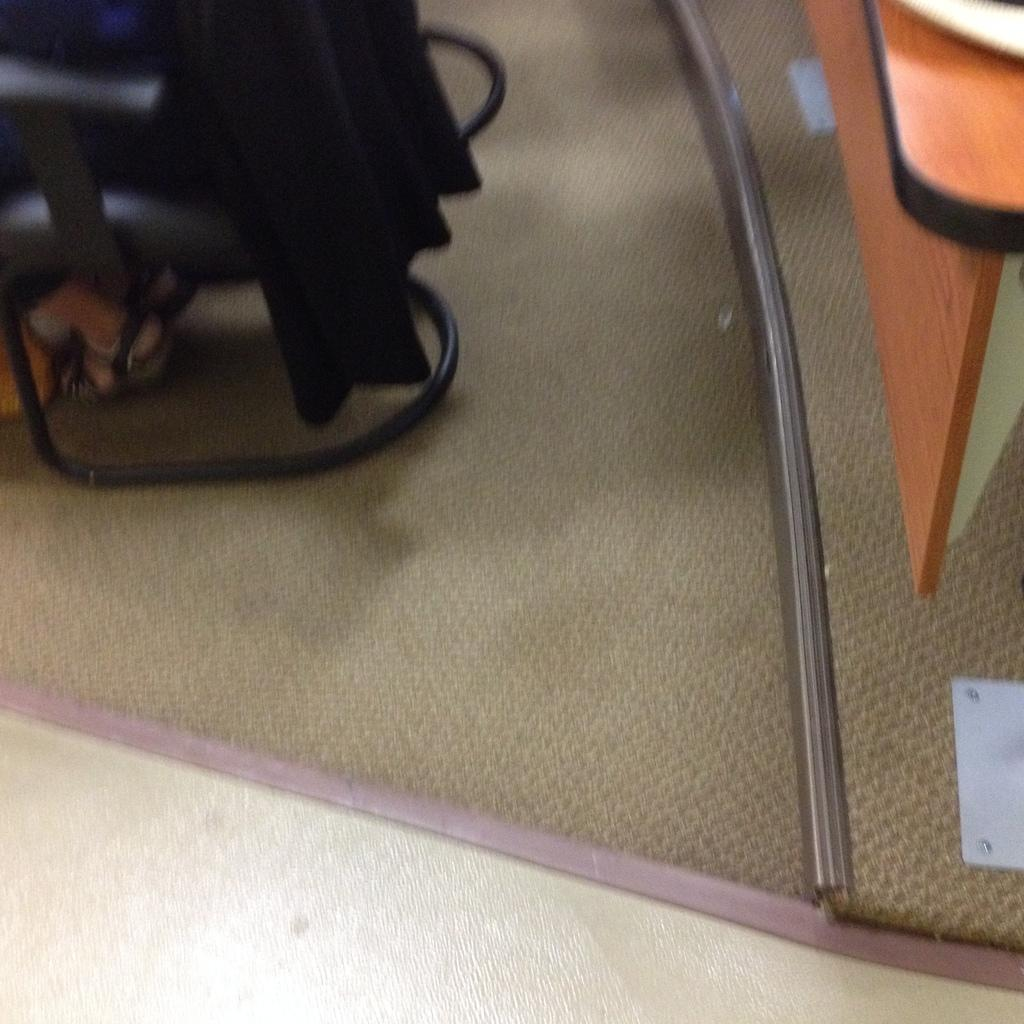What piece of furniture is located on the right side of the image? There is a table on the right side of the image. What can be seen in the background of the image? There is a chair in the background of the image. Who is sitting on the chair? A person is sitting on the chair. What is the color of the object in the image? There is an object in the image that is black in color. What type of van can be seen driving on the trail in the image? There is no van or trail present in the image. What is the relation between the person sitting on the chair and the object in the image? There is no information about a relation between the person and the object in the image. 